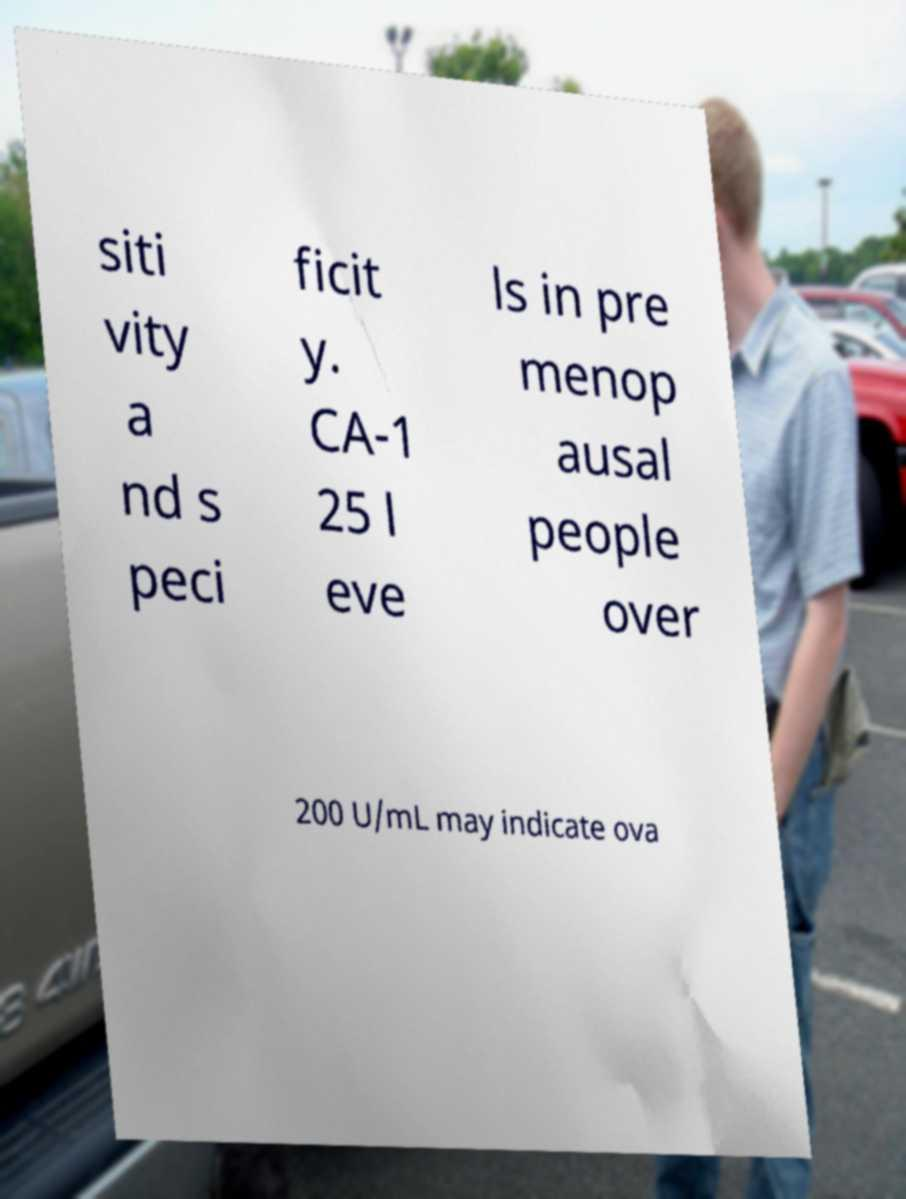Can you read and provide the text displayed in the image?This photo seems to have some interesting text. Can you extract and type it out for me? siti vity a nd s peci ficit y. CA-1 25 l eve ls in pre menop ausal people over 200 U/mL may indicate ova 